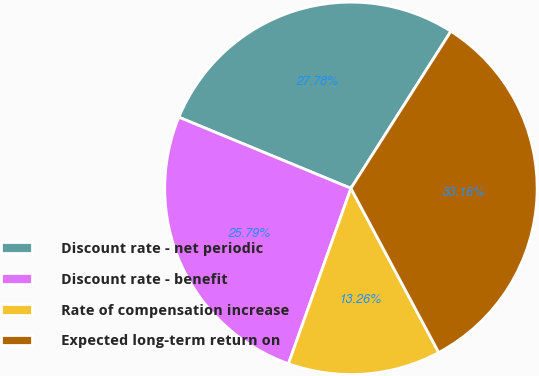Convert chart. <chart><loc_0><loc_0><loc_500><loc_500><pie_chart><fcel>Discount rate - net periodic<fcel>Discount rate - benefit<fcel>Rate of compensation increase<fcel>Expected long-term return on<nl><fcel>27.78%<fcel>25.79%<fcel>13.26%<fcel>33.16%<nl></chart> 